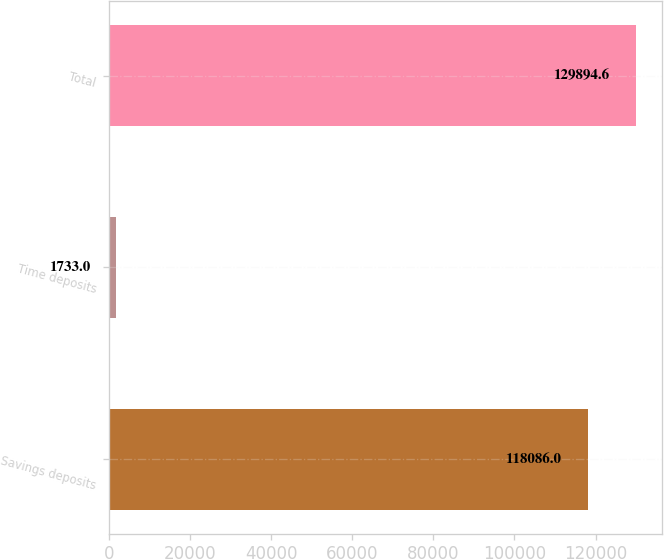<chart> <loc_0><loc_0><loc_500><loc_500><bar_chart><fcel>Savings deposits<fcel>Time deposits<fcel>Total<nl><fcel>118086<fcel>1733<fcel>129895<nl></chart> 